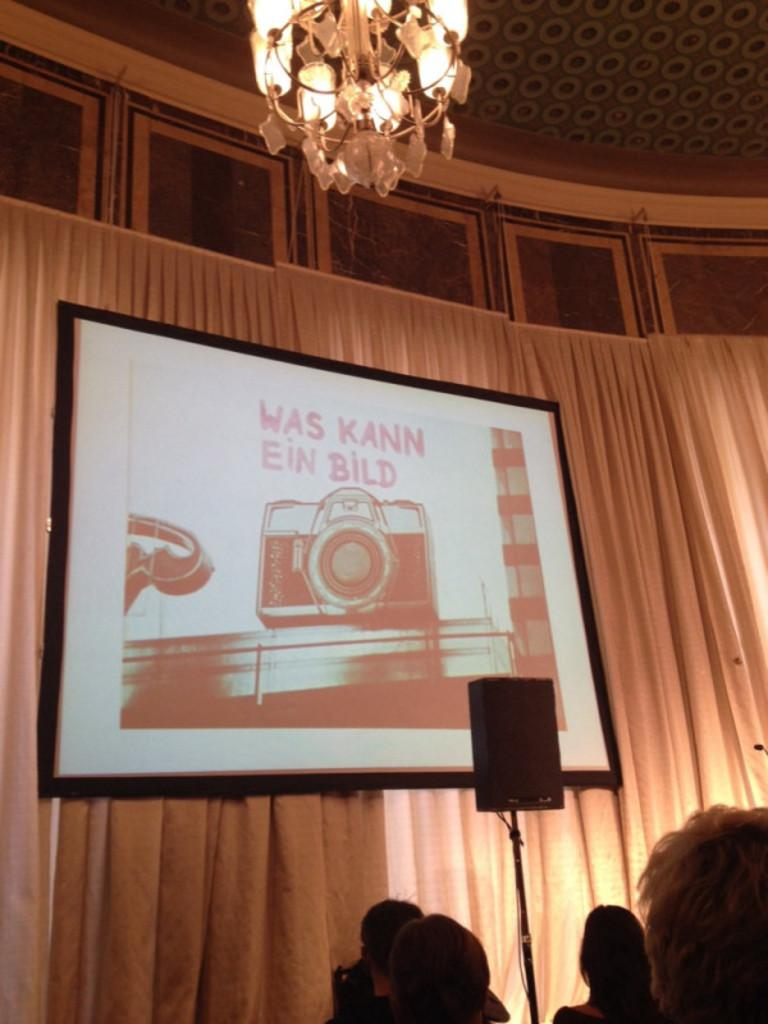Who or what can be seen at the bottom of the image? There are people at the bottom of the image. What can be seen in the background of the image? There are curtains in the background of the image. What is the main object in the middle of the image? There is a screen in the image. What is present at the top of the image? There is a ceiling at the top of the image. What is providing illumination in the image? There is a light in the image. What type of noise can be heard coming from the cars in the image? There are no cars present in the image, so no such noise can be heard. Can you describe the movement of the fly in the image? There is no fly present in the image. 